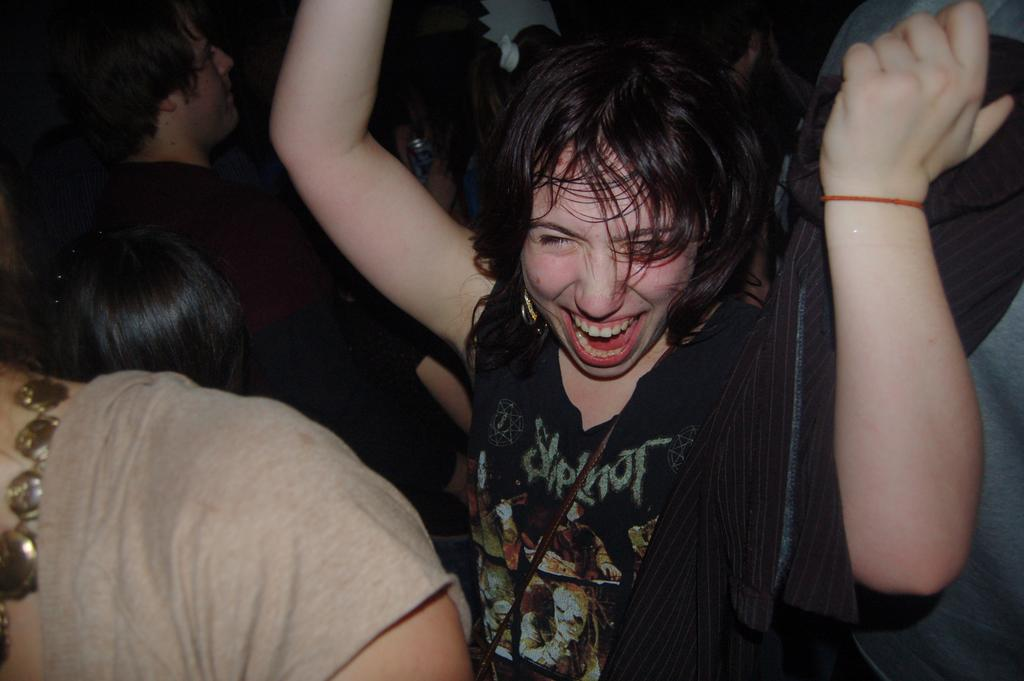What can be seen in the image? There is a group of people in the image. Can you describe any specific details about the people in the image? There is a person wearing a black dress in the image. How many kittens are sitting on the paper in the image? There are no kittens or paper present in the image. What is the person wearing a black dress thinking about in the image? We cannot determine what the person wearing a black dress is thinking about in the image, as thoughts are not visible. 